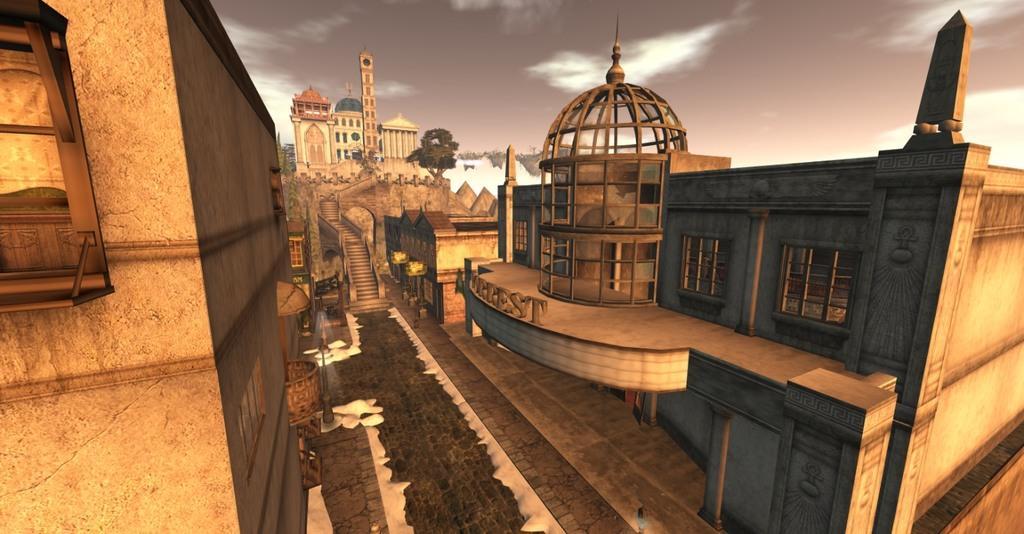In one or two sentences, can you explain what this image depicts? This is an animation, in this image there are buildings, palace, stairs, walkway, poles and some trees. At the top of the image there is sky. 